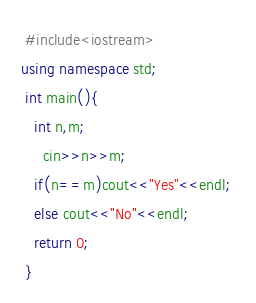Convert code to text. <code><loc_0><loc_0><loc_500><loc_500><_C++_> #include<iostream> 
using namespace std;
 int main(){ 
   int n,m; 
     cin>>n>>m; 
   if(n==m)cout<<"Yes"<<endl; 
   else cout<<"No"<<endl; 
   return 0; 
 }
</code> 